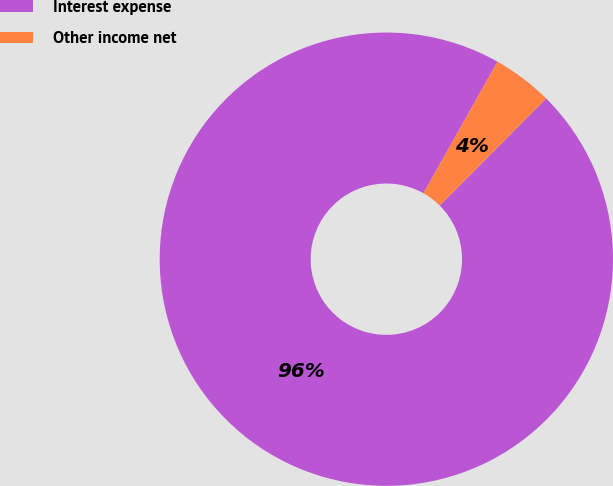<chart> <loc_0><loc_0><loc_500><loc_500><pie_chart><fcel>Interest expense<fcel>Other income net<nl><fcel>95.7%<fcel>4.3%<nl></chart> 